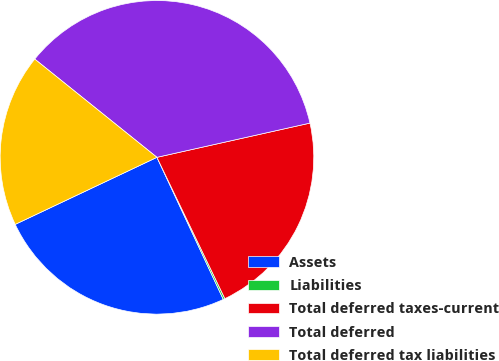<chart> <loc_0><loc_0><loc_500><loc_500><pie_chart><fcel>Assets<fcel>Liabilities<fcel>Total deferred taxes-current<fcel>Total deferred<fcel>Total deferred tax liabilities<nl><fcel>24.92%<fcel>0.18%<fcel>21.37%<fcel>35.72%<fcel>17.81%<nl></chart> 